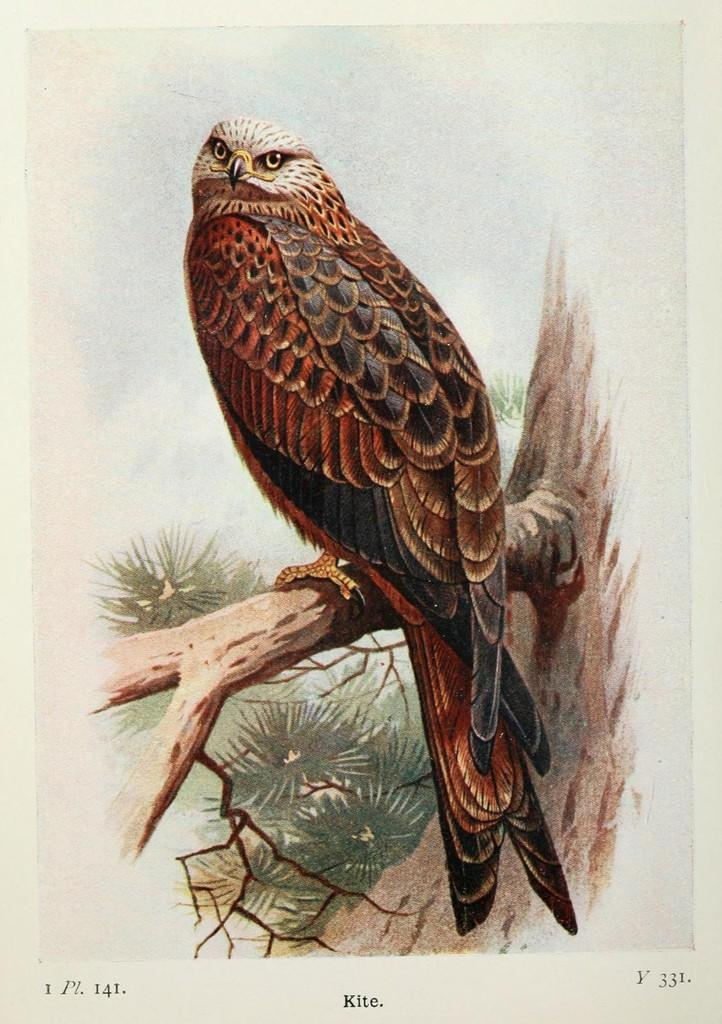What animal can be seen in the picture? There is an owl in the picture. Where is the owl located? The owl is standing on a branch of a tree. Is there any text associated with the image? Yes, there is text written below the owl. What type of sink can be seen in the picture? There is no sink present in the picture; it features an owl standing on a tree branch. What kind of property is the owl guarding in the image? The image does not depict the owl guarding any property; it simply shows the owl on a tree branch. 